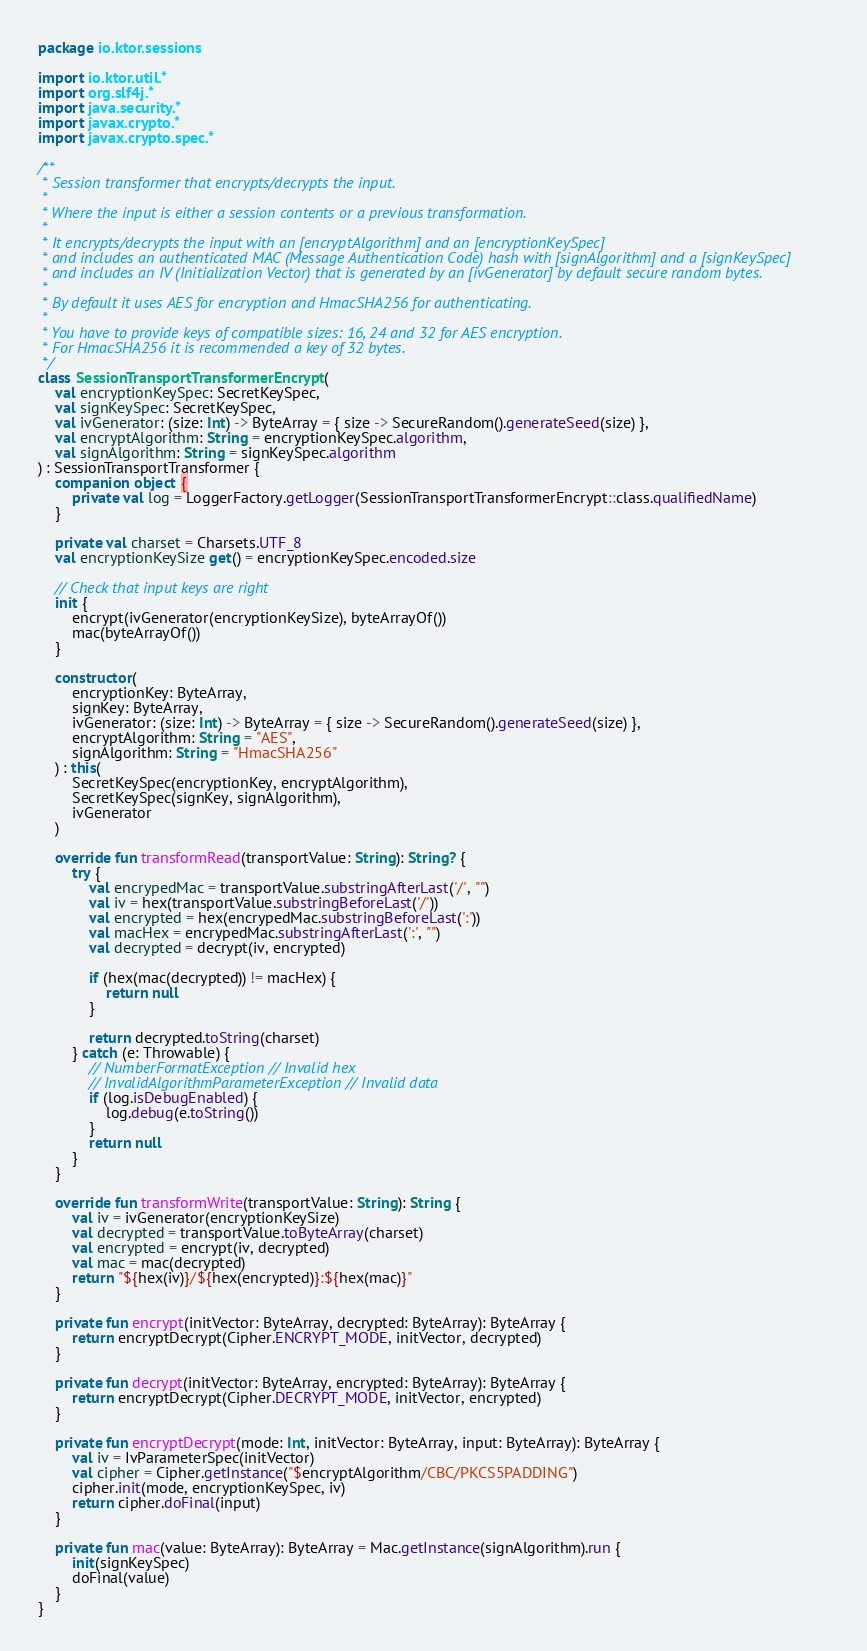Convert code to text. <code><loc_0><loc_0><loc_500><loc_500><_Kotlin_>package io.ktor.sessions

import io.ktor.util.*
import org.slf4j.*
import java.security.*
import javax.crypto.*
import javax.crypto.spec.*

/**
 * Session transformer that encrypts/decrypts the input.
 *
 * Where the input is either a session contents or a previous transformation.
 *
 * It encrypts/decrypts the input with an [encryptAlgorithm] and an [encryptionKeySpec]
 * and includes an authenticated MAC (Message Authentication Code) hash with [signAlgorithm] and a [signKeySpec]
 * and includes an IV (Initialization Vector) that is generated by an [ivGenerator] by default secure random bytes.
 *
 * By default it uses AES for encryption and HmacSHA256 for authenticating.
 *
 * You have to provide keys of compatible sizes: 16, 24 and 32 for AES encryption.
 * For HmacSHA256 it is recommended a key of 32 bytes.
 */
class SessionTransportTransformerEncrypt(
    val encryptionKeySpec: SecretKeySpec,
    val signKeySpec: SecretKeySpec,
    val ivGenerator: (size: Int) -> ByteArray = { size -> SecureRandom().generateSeed(size) },
    val encryptAlgorithm: String = encryptionKeySpec.algorithm,
    val signAlgorithm: String = signKeySpec.algorithm
) : SessionTransportTransformer {
    companion object {
        private val log = LoggerFactory.getLogger(SessionTransportTransformerEncrypt::class.qualifiedName)
    }

    private val charset = Charsets.UTF_8
    val encryptionKeySize get() = encryptionKeySpec.encoded.size

    // Check that input keys are right
    init {
        encrypt(ivGenerator(encryptionKeySize), byteArrayOf())
        mac(byteArrayOf())
    }

    constructor(
        encryptionKey: ByteArray,
        signKey: ByteArray,
        ivGenerator: (size: Int) -> ByteArray = { size -> SecureRandom().generateSeed(size) },
        encryptAlgorithm: String = "AES",
        signAlgorithm: String = "HmacSHA256"
    ) : this(
        SecretKeySpec(encryptionKey, encryptAlgorithm),
        SecretKeySpec(signKey, signAlgorithm),
        ivGenerator
    )

    override fun transformRead(transportValue: String): String? {
        try {
            val encrypedMac = transportValue.substringAfterLast('/', "")
            val iv = hex(transportValue.substringBeforeLast('/'))
            val encrypted = hex(encrypedMac.substringBeforeLast(':'))
            val macHex = encrypedMac.substringAfterLast(':', "")
            val decrypted = decrypt(iv, encrypted)

            if (hex(mac(decrypted)) != macHex) {
                return null
            }

            return decrypted.toString(charset)
        } catch (e: Throwable) {
            // NumberFormatException // Invalid hex
            // InvalidAlgorithmParameterException // Invalid data
            if (log.isDebugEnabled) {
                log.debug(e.toString())
            }
            return null
        }
    }

    override fun transformWrite(transportValue: String): String {
        val iv = ivGenerator(encryptionKeySize)
        val decrypted = transportValue.toByteArray(charset)
        val encrypted = encrypt(iv, decrypted)
        val mac = mac(decrypted)
        return "${hex(iv)}/${hex(encrypted)}:${hex(mac)}"
    }

    private fun encrypt(initVector: ByteArray, decrypted: ByteArray): ByteArray {
        return encryptDecrypt(Cipher.ENCRYPT_MODE, initVector, decrypted)
    }

    private fun decrypt(initVector: ByteArray, encrypted: ByteArray): ByteArray {
        return encryptDecrypt(Cipher.DECRYPT_MODE, initVector, encrypted)
    }

    private fun encryptDecrypt(mode: Int, initVector: ByteArray, input: ByteArray): ByteArray {
        val iv = IvParameterSpec(initVector)
        val cipher = Cipher.getInstance("$encryptAlgorithm/CBC/PKCS5PADDING")
        cipher.init(mode, encryptionKeySpec, iv)
        return cipher.doFinal(input)
    }

    private fun mac(value: ByteArray): ByteArray = Mac.getInstance(signAlgorithm).run {
        init(signKeySpec)
        doFinal(value)
    }
}
</code> 